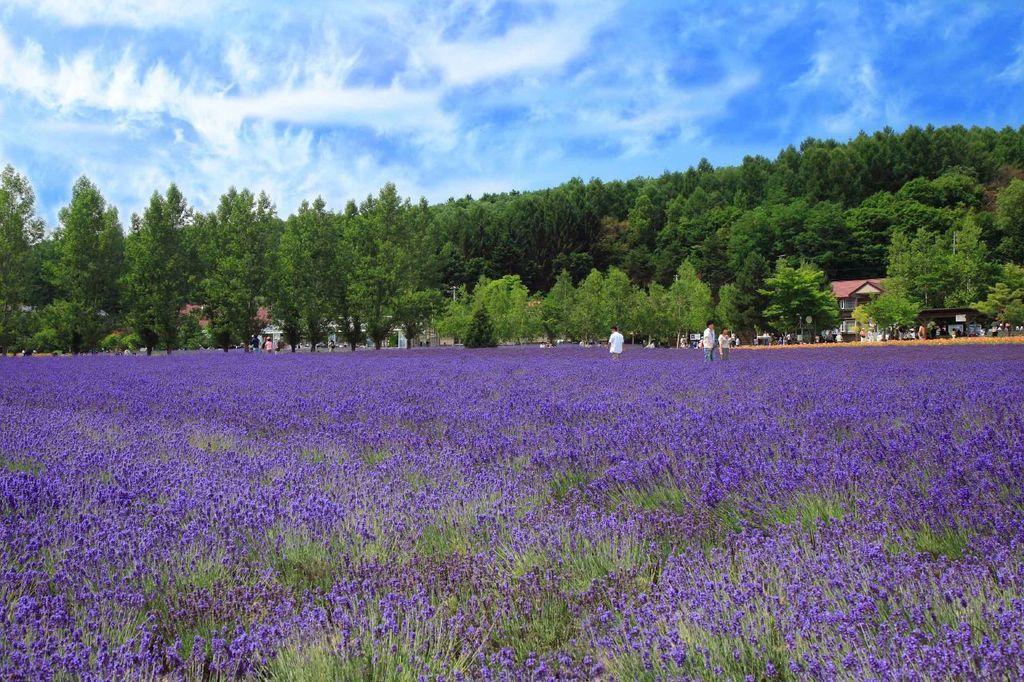Could you give a brief overview of what you see in this image? This image is taken outdoors. At the top of the image there is a sky with clouds. At the bottom of the image there are many lavender plants with flowers. In the middle of the image there are many trees and plants and there are a few houses. Three people are standing on the ground. 